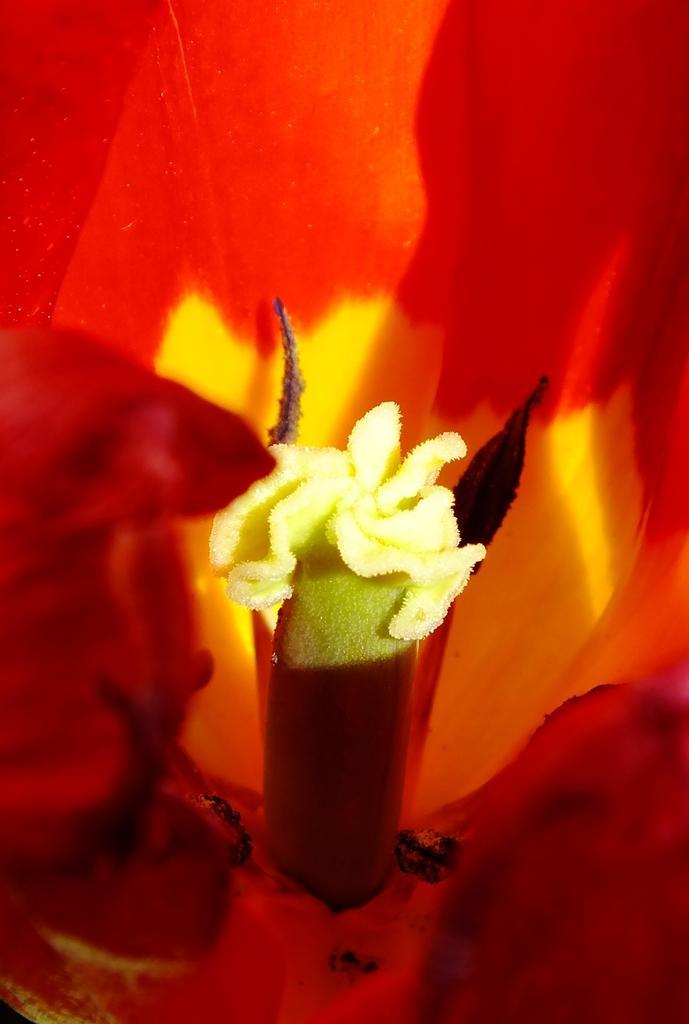Describe this image in one or two sentences. In this picture I can see a flower. 